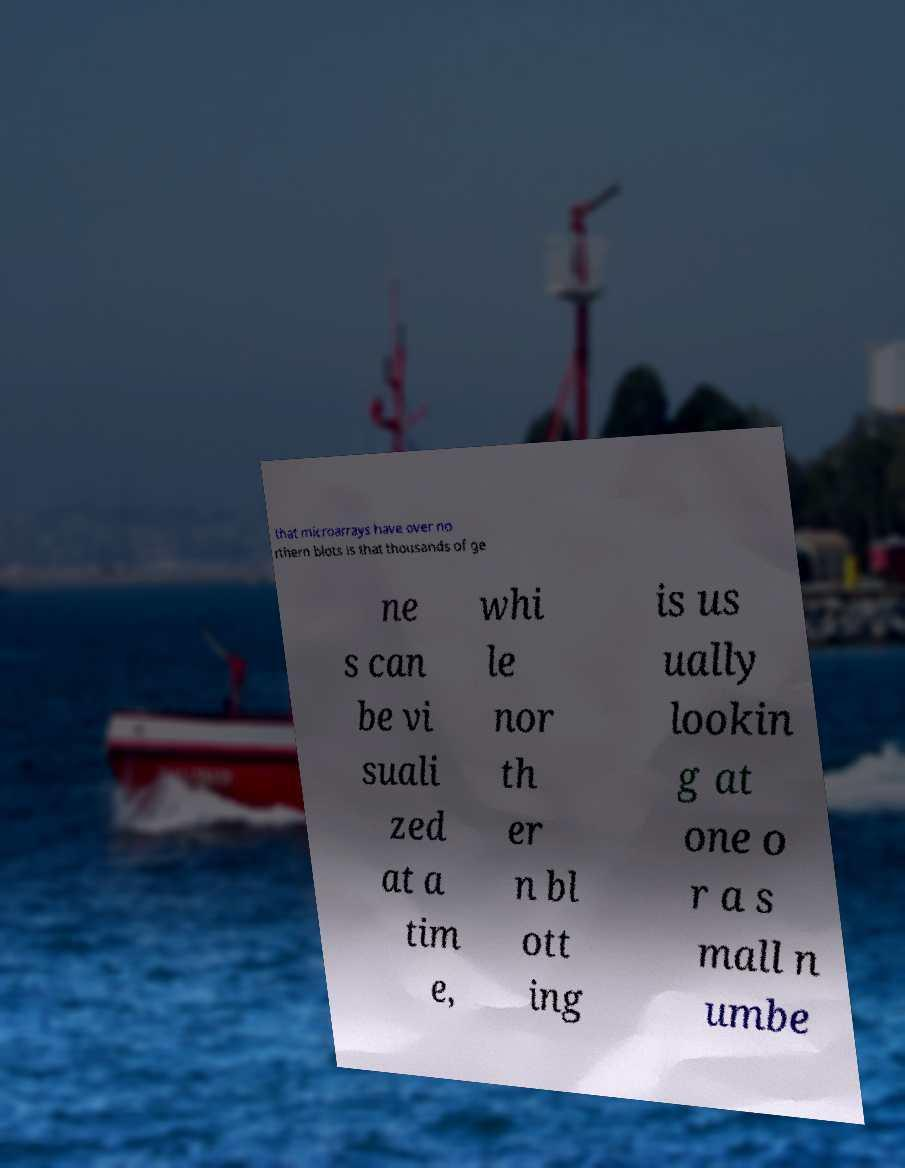Could you extract and type out the text from this image? that microarrays have over no rthern blots is that thousands of ge ne s can be vi suali zed at a tim e, whi le nor th er n bl ott ing is us ually lookin g at one o r a s mall n umbe 